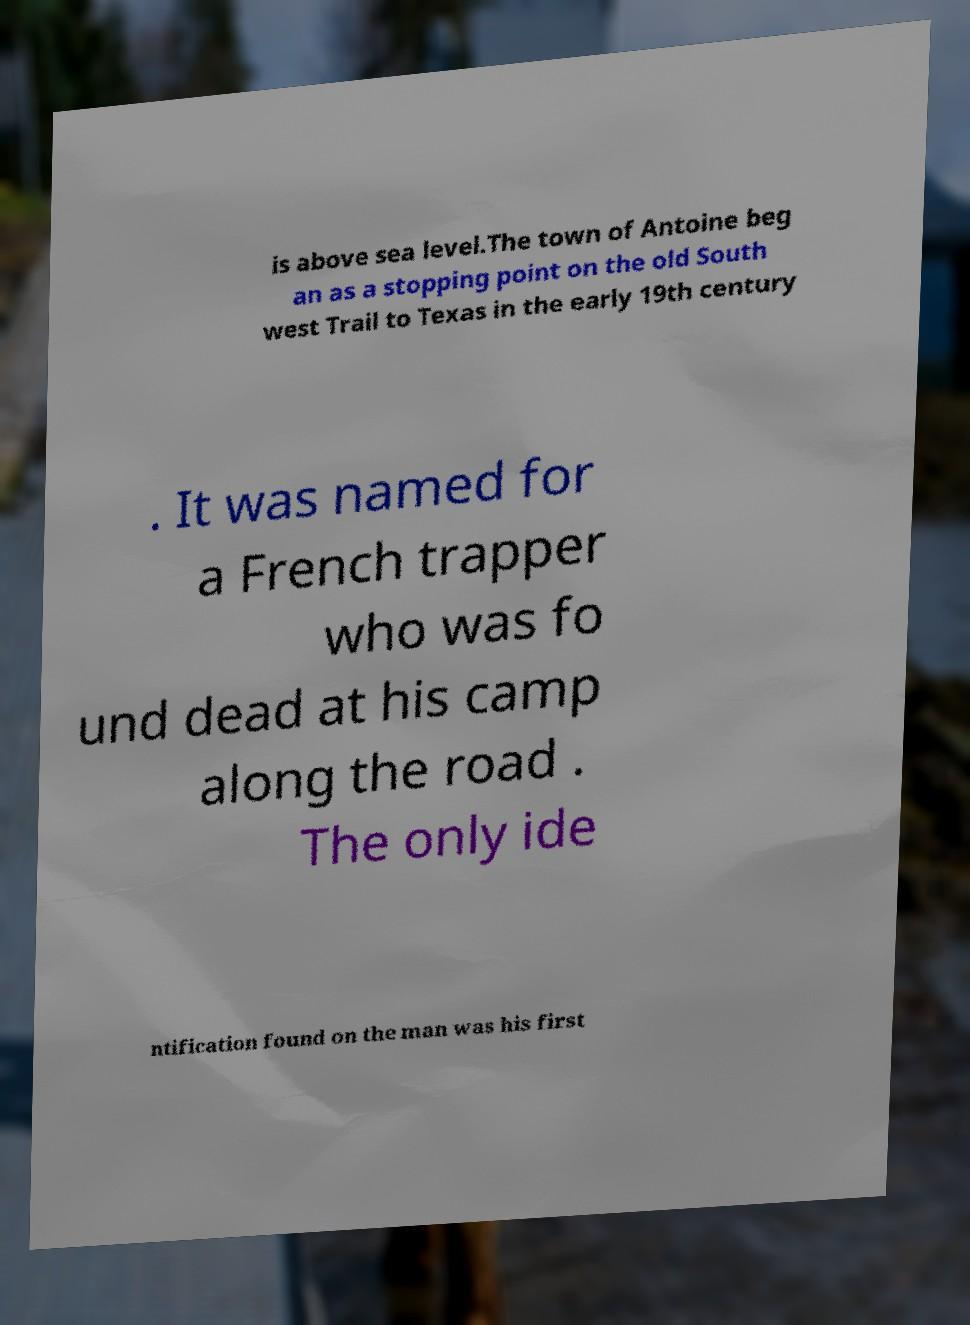Can you accurately transcribe the text from the provided image for me? is above sea level.The town of Antoine beg an as a stopping point on the old South west Trail to Texas in the early 19th century . It was named for a French trapper who was fo und dead at his camp along the road . The only ide ntification found on the man was his first 